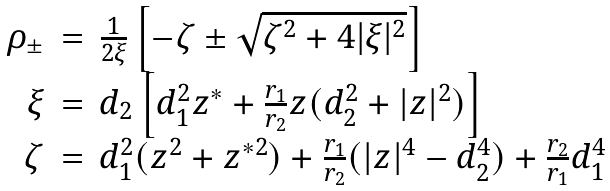<formula> <loc_0><loc_0><loc_500><loc_500>\begin{array} { r c l } \rho _ { \pm } & = & \frac { 1 } { 2 \xi } \left [ - \zeta \pm \sqrt { \zeta ^ { 2 } + 4 | \xi | ^ { 2 } } \right ] \\ \xi & = & d _ { 2 } \left [ d _ { 1 } ^ { 2 } z ^ { * } + \frac { r _ { 1 } } { r _ { 2 } } z ( d _ { 2 } ^ { 2 } + | z | ^ { 2 } ) \right ] \\ \zeta & = & d _ { 1 } ^ { 2 } ( z ^ { 2 } + z ^ { * 2 } ) + \frac { r _ { 1 } } { r _ { 2 } } ( | z | ^ { 4 } - d _ { 2 } ^ { 4 } ) + \frac { r _ { 2 } } { r _ { 1 } } d _ { 1 } ^ { 4 } \end{array}</formula> 